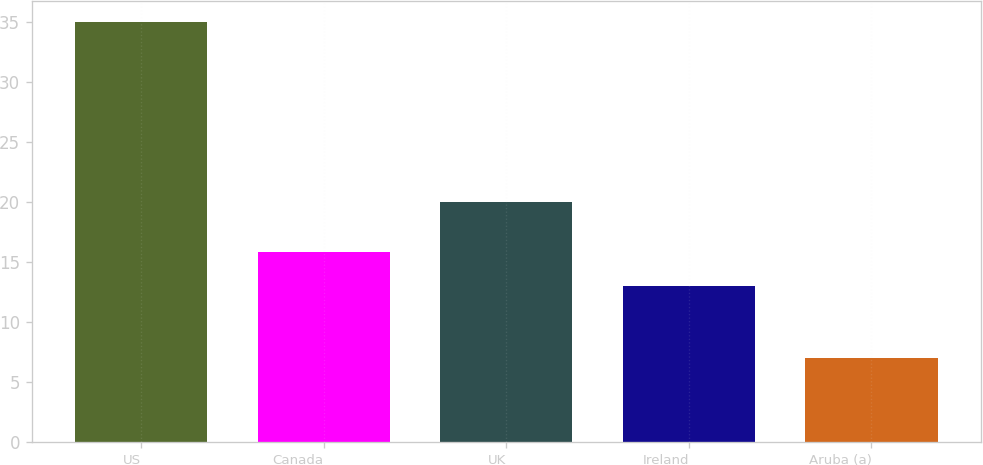Convert chart to OTSL. <chart><loc_0><loc_0><loc_500><loc_500><bar_chart><fcel>US<fcel>Canada<fcel>UK<fcel>Ireland<fcel>Aruba (a)<nl><fcel>35<fcel>15.8<fcel>20<fcel>13<fcel>7<nl></chart> 